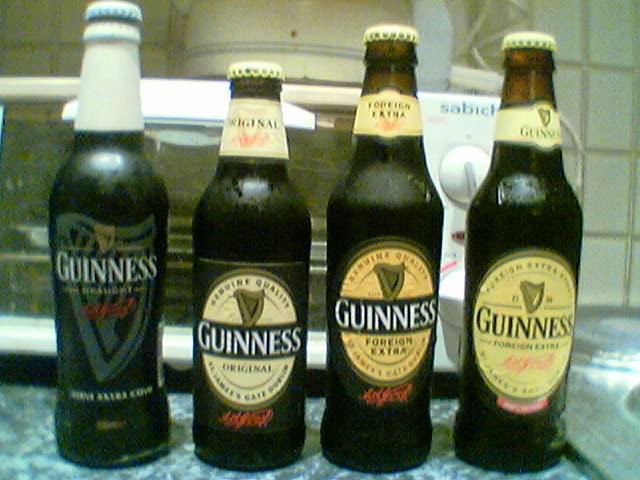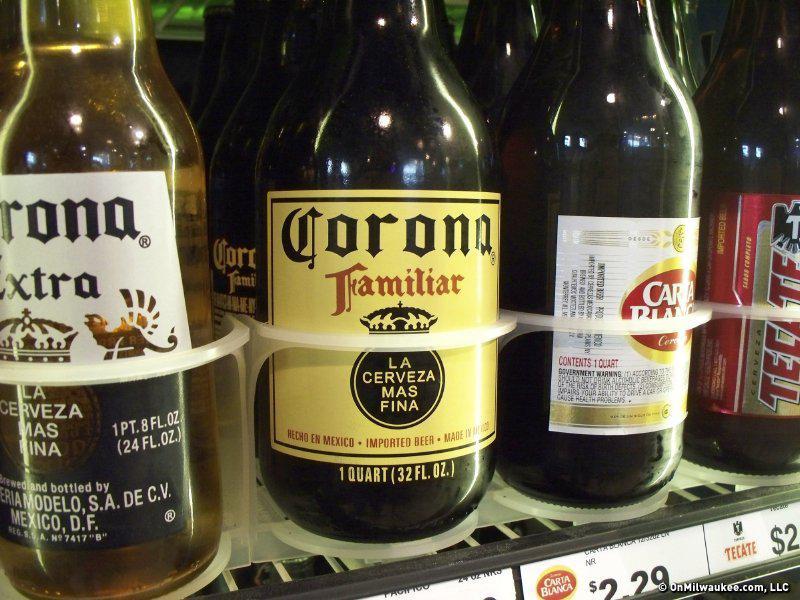The first image is the image on the left, the second image is the image on the right. Given the left and right images, does the statement "The left and right image contains the same number of glass drinking bottles." hold true? Answer yes or no. Yes. The first image is the image on the left, the second image is the image on the right. Assess this claim about the two images: "There are multiple of the same bottles next to each other.". Correct or not? Answer yes or no. No. 